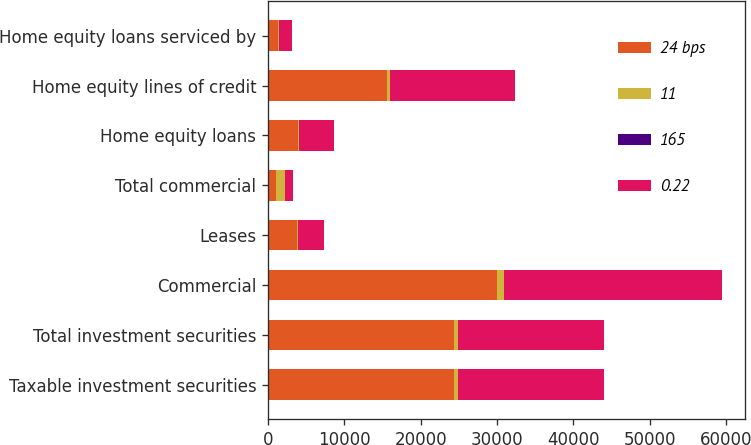Convert chart to OTSL. <chart><loc_0><loc_0><loc_500><loc_500><stacked_bar_chart><ecel><fcel>Taxable investment securities<fcel>Total investment securities<fcel>Commercial<fcel>Leases<fcel>Total commercial<fcel>Home equity loans<fcel>Home equity lines of credit<fcel>Home equity loans serviced by<nl><fcel>24 bps<fcel>24319<fcel>24330<fcel>29993<fcel>3776<fcel>1043<fcel>3877<fcel>15552<fcel>1352<nl><fcel>11<fcel>619<fcel>619<fcel>900<fcel>103<fcel>1186<fcel>205<fcel>450<fcel>91<nl><fcel>165<fcel>2.55<fcel>2.55<fcel>2.96<fcel>2.73<fcel>2.86<fcel>5.29<fcel>2.89<fcel>6.75<nl><fcel>0.22<fcel>19062<fcel>19074<fcel>28654<fcel>3463<fcel>1043<fcel>4606<fcel>16337<fcel>1724<nl></chart> 